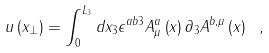Convert formula to latex. <formula><loc_0><loc_0><loc_500><loc_500>u \left ( x _ { \perp } \right ) = \int _ { 0 } ^ { L _ { 3 } } d x _ { 3 } \epsilon ^ { a b 3 } A ^ { a } _ { \mu } \left ( x \right ) \partial _ { 3 } A ^ { b , \mu } \left ( x \right ) \ ,</formula> 